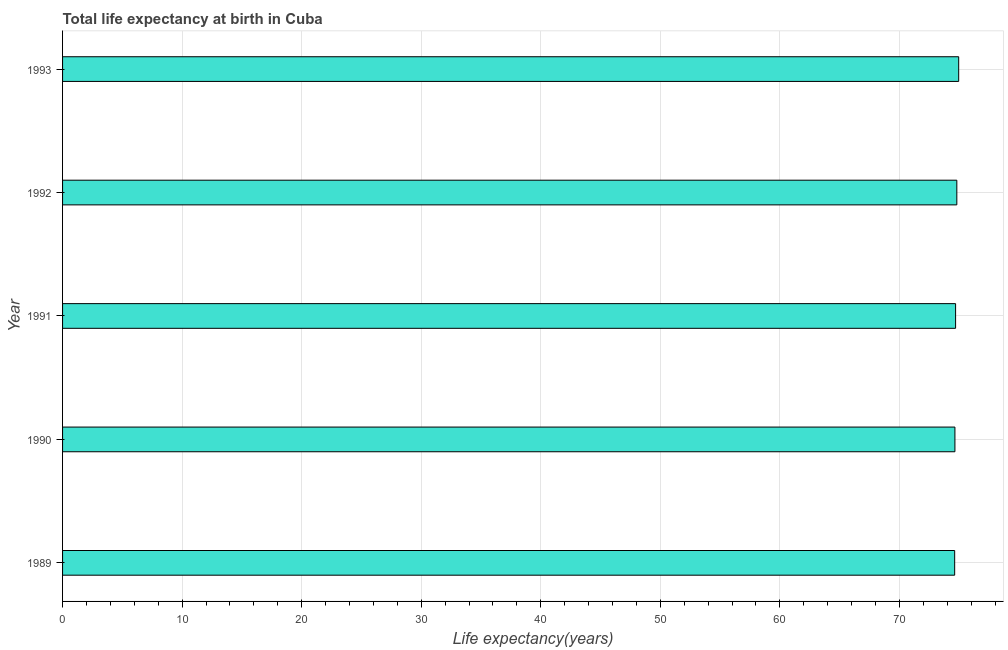Does the graph contain any zero values?
Offer a very short reply. No. Does the graph contain grids?
Your response must be concise. Yes. What is the title of the graph?
Your response must be concise. Total life expectancy at birth in Cuba. What is the label or title of the X-axis?
Offer a terse response. Life expectancy(years). What is the life expectancy at birth in 1993?
Your answer should be compact. 74.96. Across all years, what is the maximum life expectancy at birth?
Offer a very short reply. 74.96. Across all years, what is the minimum life expectancy at birth?
Keep it short and to the point. 74.62. In which year was the life expectancy at birth maximum?
Ensure brevity in your answer.  1993. What is the sum of the life expectancy at birth?
Make the answer very short. 373.73. What is the difference between the life expectancy at birth in 1990 and 1992?
Keep it short and to the point. -0.16. What is the average life expectancy at birth per year?
Make the answer very short. 74.75. What is the median life expectancy at birth?
Your answer should be very brief. 74.7. In how many years, is the life expectancy at birth greater than 28 years?
Offer a terse response. 5. Do a majority of the years between 1991 and 1989 (inclusive) have life expectancy at birth greater than 46 years?
Ensure brevity in your answer.  Yes. Is the life expectancy at birth in 1989 less than that in 1991?
Your answer should be very brief. Yes. Is the difference between the life expectancy at birth in 1990 and 1992 greater than the difference between any two years?
Make the answer very short. No. What is the difference between the highest and the second highest life expectancy at birth?
Your answer should be compact. 0.16. What is the difference between the highest and the lowest life expectancy at birth?
Keep it short and to the point. 0.34. Are all the bars in the graph horizontal?
Provide a succinct answer. Yes. What is the Life expectancy(years) of 1989?
Offer a terse response. 74.62. What is the Life expectancy(years) in 1990?
Your response must be concise. 74.64. What is the Life expectancy(years) in 1991?
Provide a short and direct response. 74.7. What is the Life expectancy(years) in 1992?
Make the answer very short. 74.8. What is the Life expectancy(years) in 1993?
Give a very brief answer. 74.96. What is the difference between the Life expectancy(years) in 1989 and 1990?
Ensure brevity in your answer.  -0.02. What is the difference between the Life expectancy(years) in 1989 and 1991?
Your response must be concise. -0.08. What is the difference between the Life expectancy(years) in 1989 and 1992?
Give a very brief answer. -0.18. What is the difference between the Life expectancy(years) in 1989 and 1993?
Make the answer very short. -0.34. What is the difference between the Life expectancy(years) in 1990 and 1991?
Your answer should be very brief. -0.06. What is the difference between the Life expectancy(years) in 1990 and 1992?
Your answer should be very brief. -0.16. What is the difference between the Life expectancy(years) in 1990 and 1993?
Ensure brevity in your answer.  -0.32. What is the difference between the Life expectancy(years) in 1991 and 1992?
Offer a terse response. -0.1. What is the difference between the Life expectancy(years) in 1991 and 1993?
Provide a succinct answer. -0.26. What is the difference between the Life expectancy(years) in 1992 and 1993?
Ensure brevity in your answer.  -0.16. What is the ratio of the Life expectancy(years) in 1990 to that in 1992?
Give a very brief answer. 1. What is the ratio of the Life expectancy(years) in 1991 to that in 1992?
Make the answer very short. 1. What is the ratio of the Life expectancy(years) in 1991 to that in 1993?
Keep it short and to the point. 1. What is the ratio of the Life expectancy(years) in 1992 to that in 1993?
Provide a succinct answer. 1. 